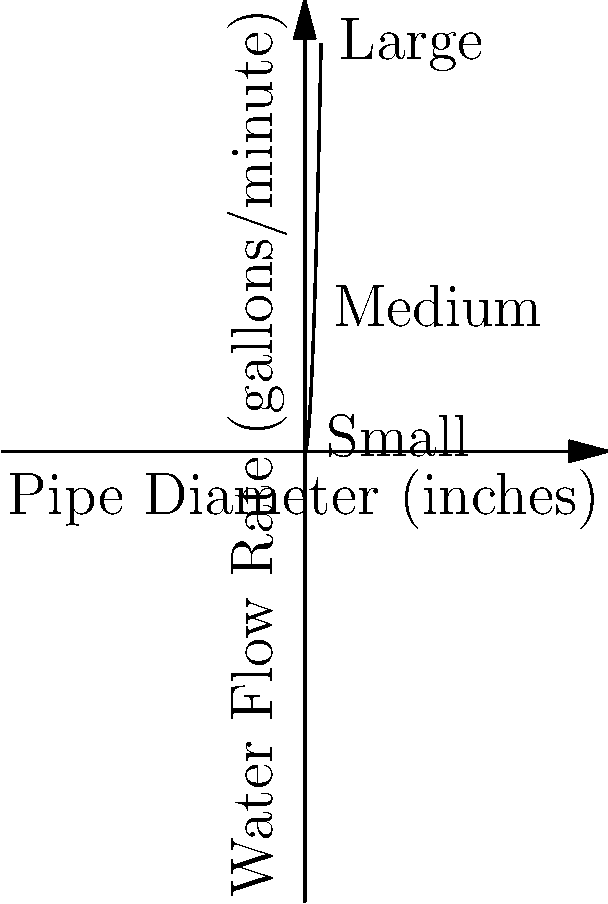Looking at the graph, which shows how water flows through different sized pipes, about how many more gallons per minute does water flow through the large pipe compared to the small pipe? Let's break this down step-by-step:

1. First, we need to identify the small and large pipes on the graph.
   - The small pipe is labeled at x = 1 inch
   - The large pipe is labeled at x = 5 inches

2. Now, let's estimate the flow rates for each pipe:
   - For the small pipe (1 inch), the flow rate is about 5 gallons/minute
   - For the large pipe (5 inches), the flow rate is about 125 gallons/minute

3. To find the difference, we subtract:
   125 gallons/minute - 5 gallons/minute = 120 gallons/minute

4. The question asks for an approximate answer, so we can round this to 120 gallons/minute.

This shows that water flows much faster through larger pipes, which is why bigger pipes are used for main water lines in houses and cities.
Answer: Approximately 120 gallons/minute 